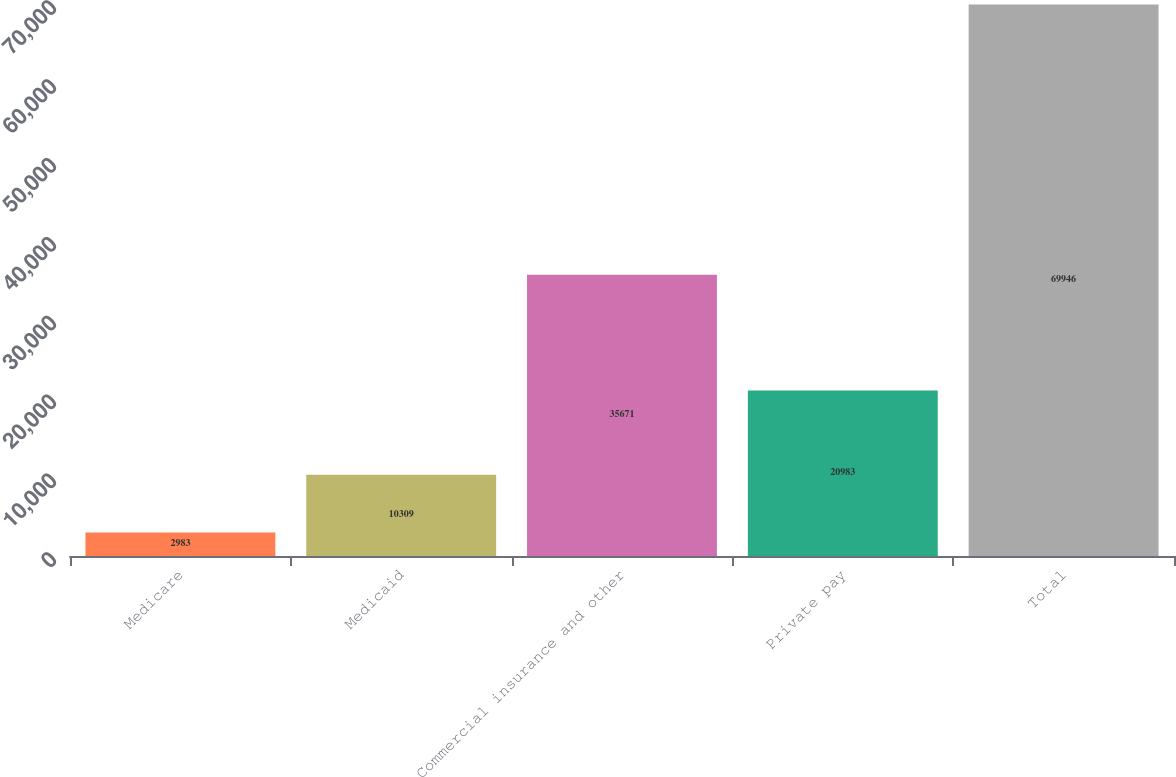Convert chart. <chart><loc_0><loc_0><loc_500><loc_500><bar_chart><fcel>Medicare<fcel>Medicaid<fcel>Commercial insurance and other<fcel>Private pay<fcel>Total<nl><fcel>2983<fcel>10309<fcel>35671<fcel>20983<fcel>69946<nl></chart> 